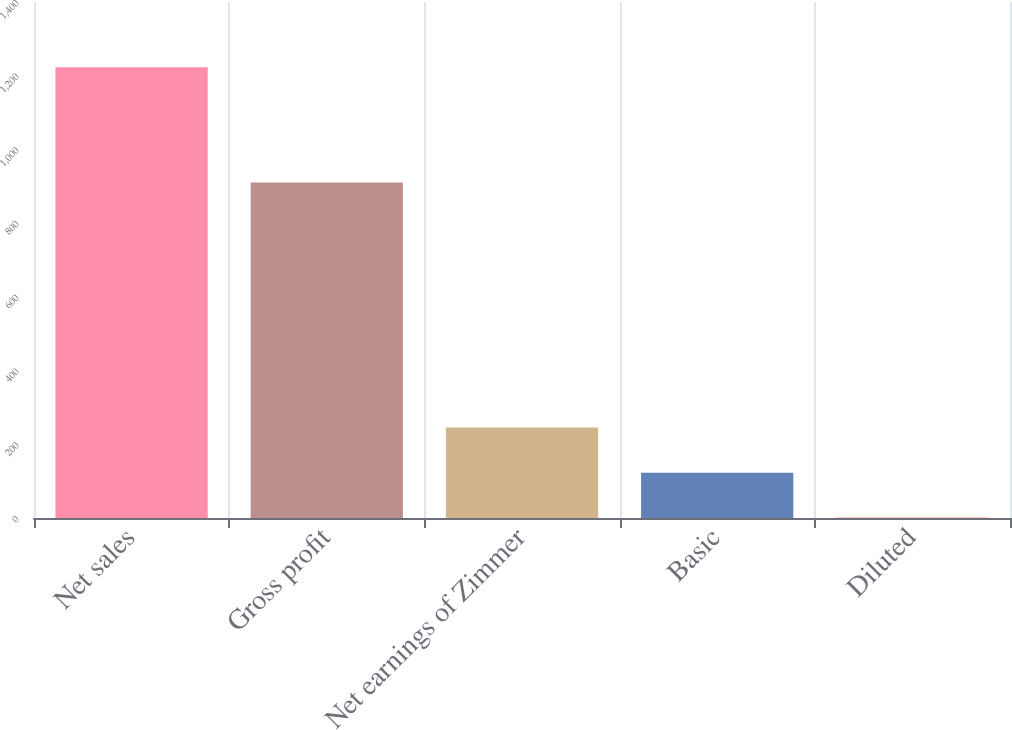Convert chart to OTSL. <chart><loc_0><loc_0><loc_500><loc_500><bar_chart><fcel>Net sales<fcel>Gross profit<fcel>Net earnings of Zimmer<fcel>Basic<fcel>Diluted<nl><fcel>1222.9<fcel>910<fcel>245.31<fcel>123.11<fcel>0.91<nl></chart> 